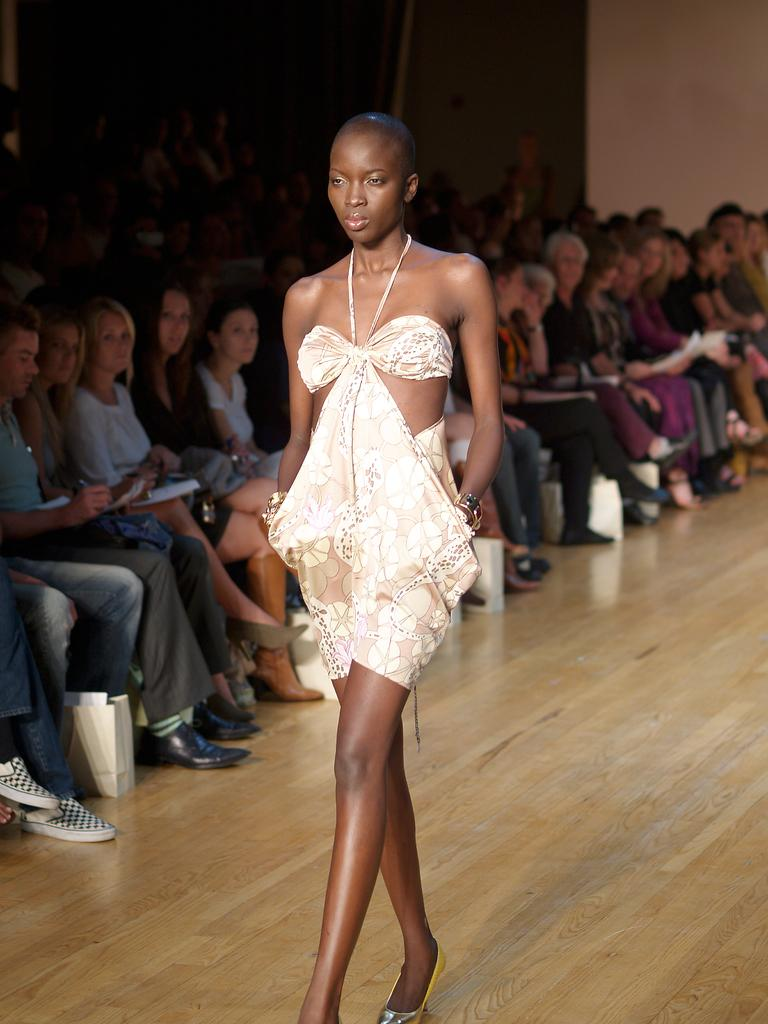What is the lady in the image doing? The lady is walking in the image. What type of surface is the lady walking on? The lady is walking on a wooden surface. What are the people in the image doing? The people in the image are sitting. Where is the packet located in the image? The packet is on the floor on the left side of the image. Can you see a toad hopping near the people in the image? There is no toad present in the image. What type of match is being played by the people in the image? There is no match or game being played by the people in the image; they are simply sitting. 